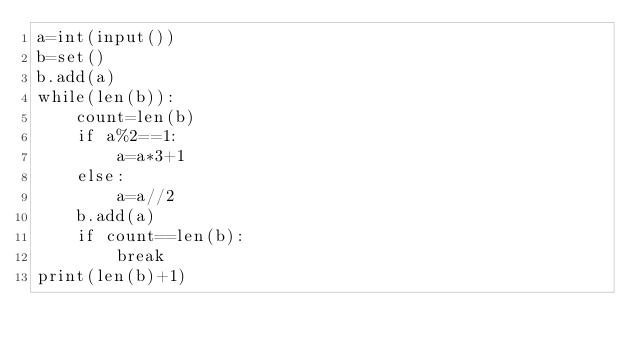Convert code to text. <code><loc_0><loc_0><loc_500><loc_500><_Python_>a=int(input())
b=set()
b.add(a)
while(len(b)):
    count=len(b)
    if a%2==1:
        a=a*3+1
    else:
        a=a//2
    b.add(a)
    if count==len(b):
        break
print(len(b)+1)
</code> 